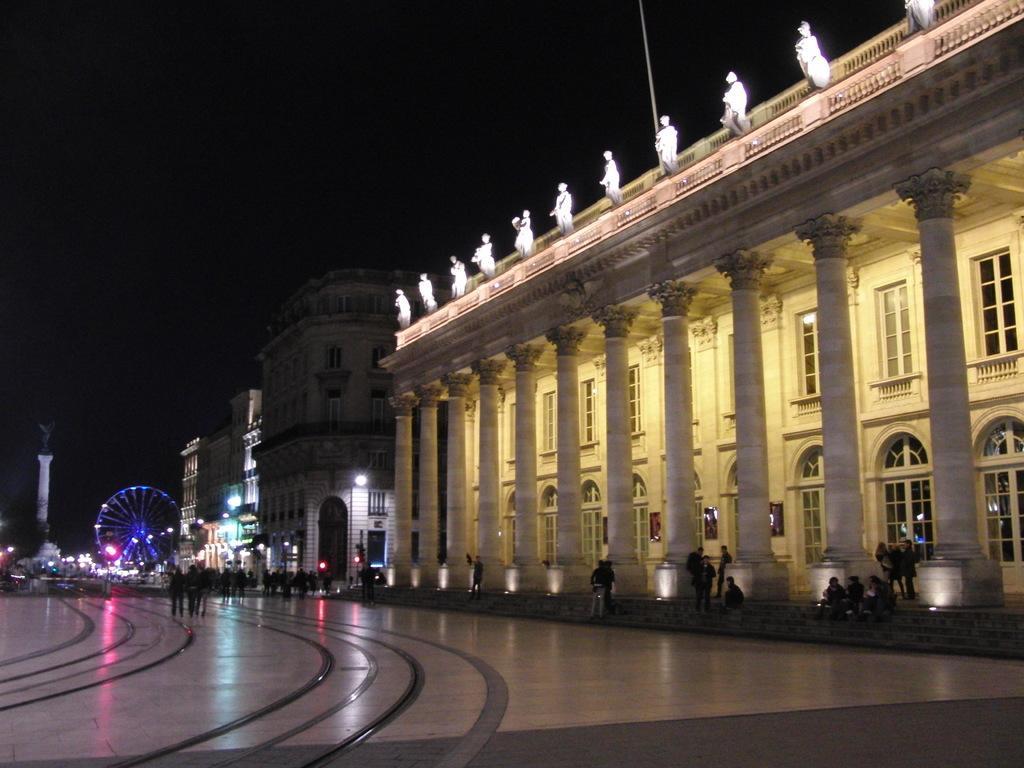In one or two sentences, can you explain what this image depicts? In this image in front there are people walking on the floor. On the right side of the image there are buildings. There are people sitting on the stairs. In the background of the image there is a giant wheel. There are lights. There is sky. 